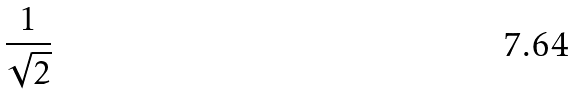<formula> <loc_0><loc_0><loc_500><loc_500>\frac { 1 } { \sqrt { 2 } }</formula> 